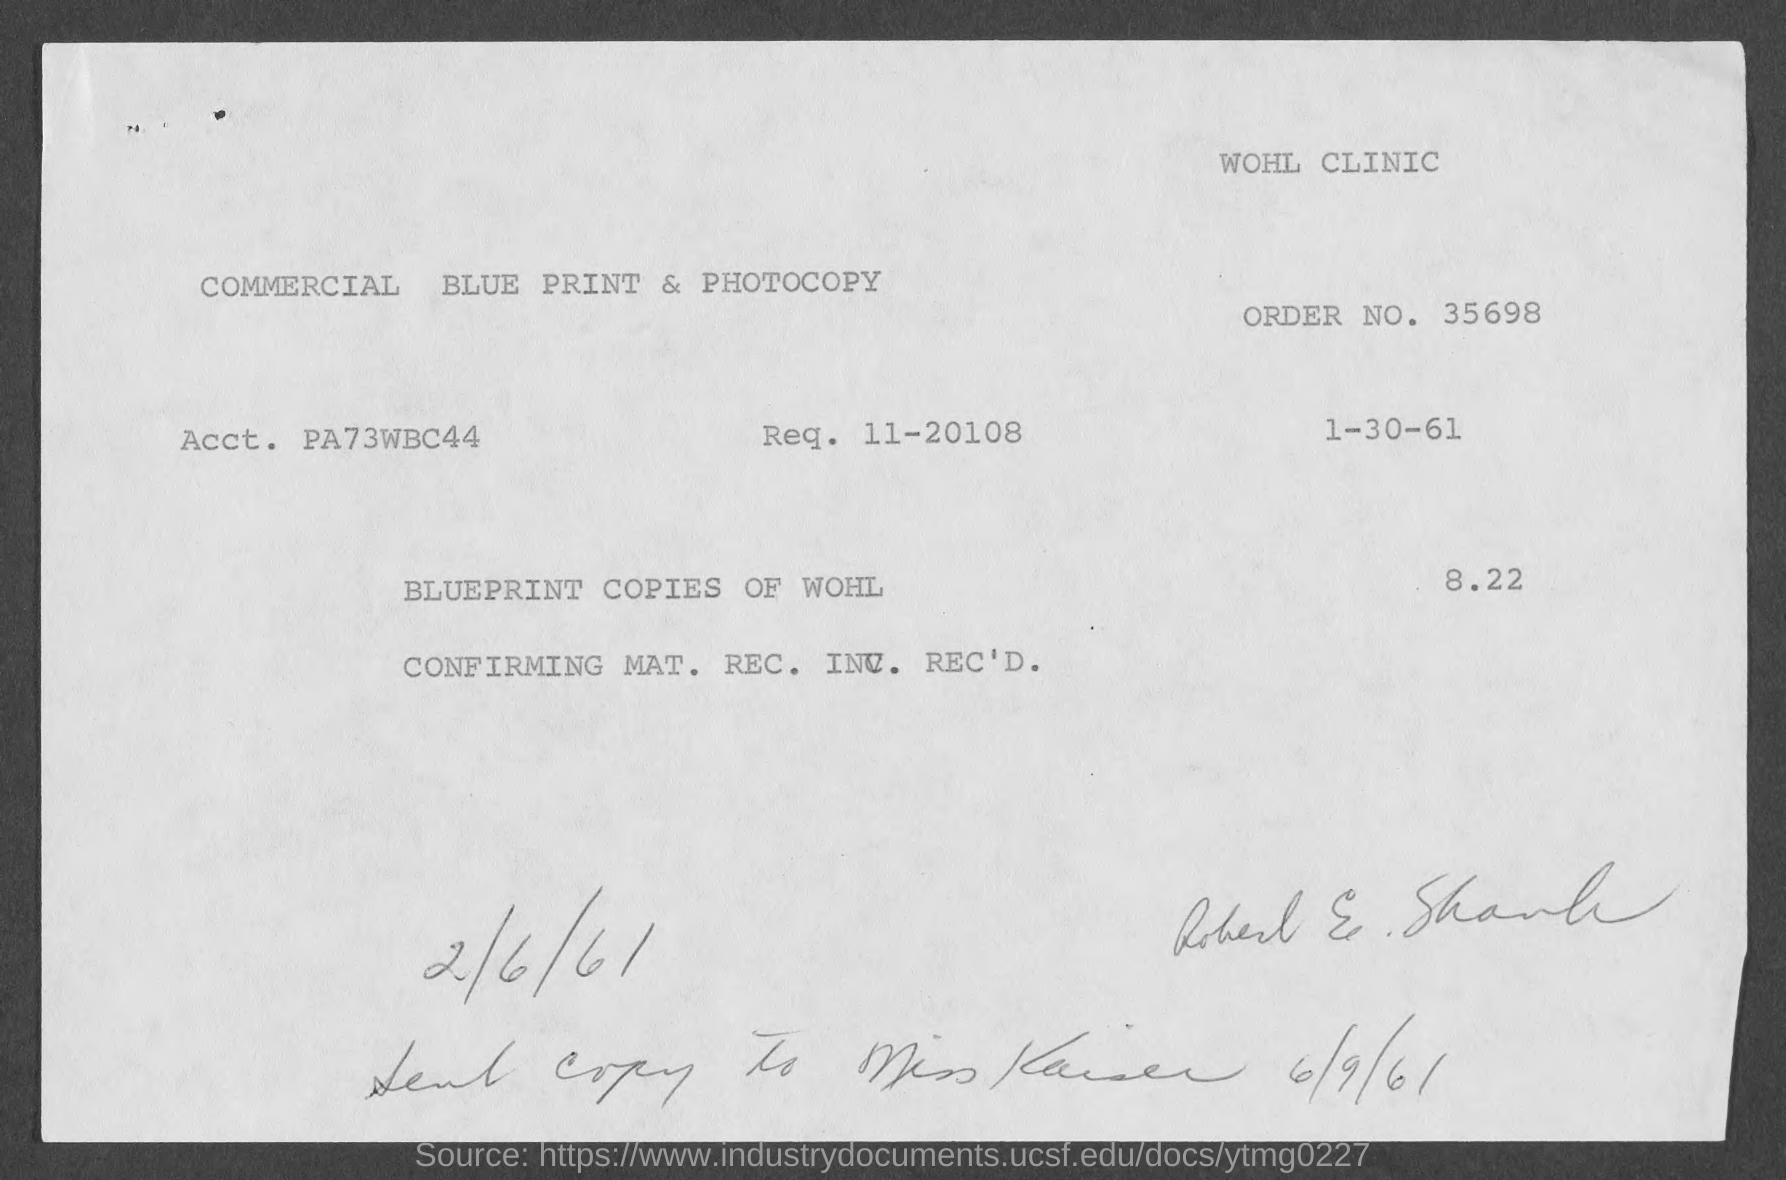What is the order no.?
Your response must be concise. 35698. What is acct. ?
Offer a very short reply. PA73WBC44. 